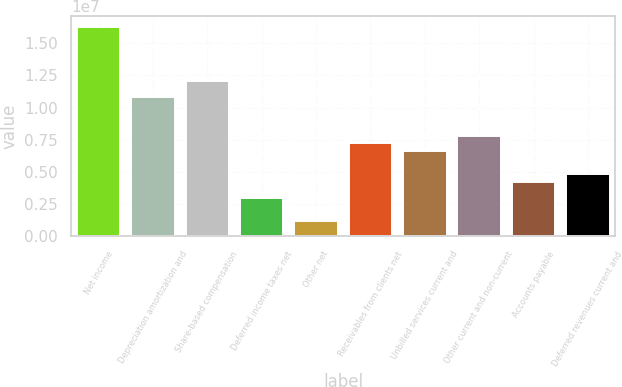<chart> <loc_0><loc_0><loc_500><loc_500><bar_chart><fcel>Net income<fcel>Depreciation amortization and<fcel>Share-based compensation<fcel>Deferred income taxes net<fcel>Other net<fcel>Receivables from clients net<fcel>Unbilled services current and<fcel>Other current and non-current<fcel>Accounts payable<fcel>Deferred revenues current and<nl><fcel>1.62649e+07<fcel>1.08447e+07<fcel>1.20492e+07<fcel>3.01544e+06<fcel>1.20869e+06<fcel>7.23119e+06<fcel>6.62894e+06<fcel>7.83344e+06<fcel>4.21994e+06<fcel>4.82219e+06<nl></chart> 